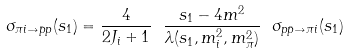Convert formula to latex. <formula><loc_0><loc_0><loc_500><loc_500>\sigma _ { \pi i \to \bar { p } p } ( s _ { 1 } ) = \frac { 4 } { 2 J _ { i } + 1 } \ \frac { s _ { 1 } - 4 m ^ { 2 } } { \lambda ( s _ { 1 } , m ^ { 2 } _ { i } , m ^ { 2 } _ { \pi } ) } \ \sigma _ { p \bar { p } \to \pi i } ( s _ { 1 } )</formula> 